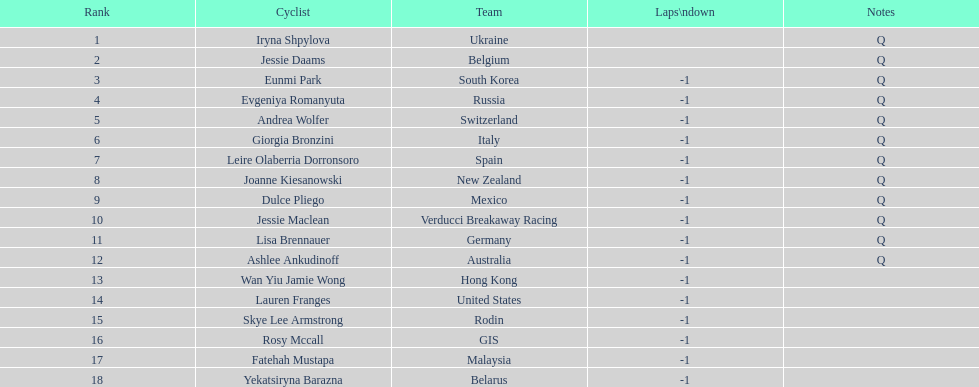What two cyclists come from teams with no laps down? Iryna Shpylova, Jessie Daams. 